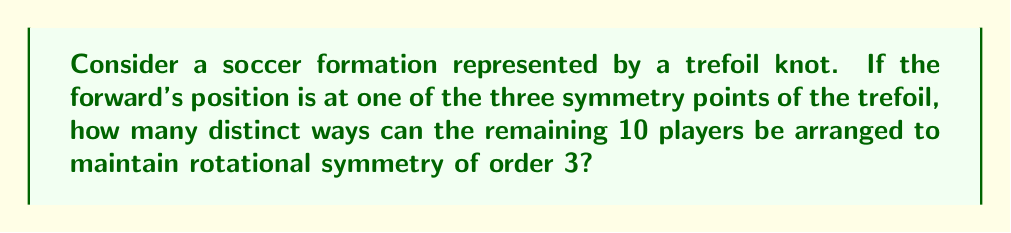Provide a solution to this math problem. Let's approach this step-by-step:

1) A trefoil knot has 3-fold rotational symmetry, meaning it looks the same after a rotation of 120° or 240°.

2) With the forward fixed at one symmetry point, we need to arrange the remaining 10 players in a way that preserves this symmetry.

3) To maintain 3-fold symmetry, we need to divide the remaining 10 players into 3 equal groups, plus 1 player at the center (if needed).

4) 10 players can be divided into 3 groups of 3, with 1 player left over: $10 = 3 \times 3 + 1$

5) The single player left over will be placed at the center of rotation to maintain symmetry.

6) Now, we need to calculate how many ways we can arrange 3 players in each of the 3 symmetric positions.

7) This is equivalent to choosing 3 players out of 9 (as 1 is at the center), which can be done in $\binom{9}{3}$ ways.

8) $\binom{9}{3} = \frac{9!}{3!(9-3)!} = \frac{9!}{3!6!} = 84$

9) Once we've chosen 3 players for one position, the other two positions are automatically filled to maintain symmetry.

10) Therefore, there are 84 distinct ways to arrange the players while maintaining rotational symmetry.
Answer: 84 